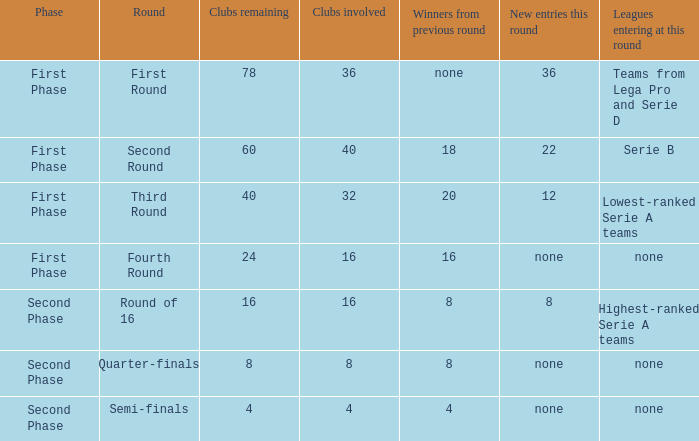With 8 clubs participating, what quantity can be determined from victors in the prior round? 8.0. 